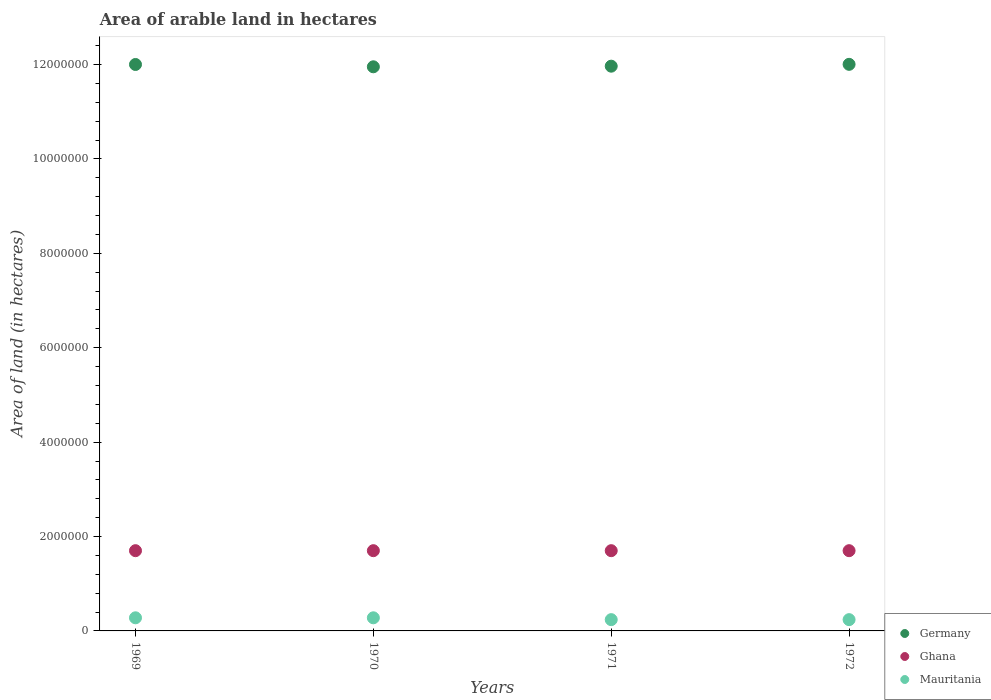What is the total arable land in Ghana in 1972?
Ensure brevity in your answer.  1.70e+06. Across all years, what is the maximum total arable land in Germany?
Your response must be concise. 1.20e+07. Across all years, what is the minimum total arable land in Ghana?
Offer a terse response. 1.70e+06. In which year was the total arable land in Mauritania maximum?
Your answer should be compact. 1969. What is the total total arable land in Germany in the graph?
Provide a succinct answer. 4.79e+07. What is the difference between the total arable land in Germany in 1969 and that in 1970?
Give a very brief answer. 4.90e+04. What is the difference between the total arable land in Germany in 1969 and the total arable land in Mauritania in 1970?
Ensure brevity in your answer.  1.17e+07. What is the average total arable land in Ghana per year?
Offer a very short reply. 1.70e+06. In the year 1972, what is the difference between the total arable land in Germany and total arable land in Ghana?
Your response must be concise. 1.03e+07. What is the ratio of the total arable land in Mauritania in 1969 to that in 1971?
Ensure brevity in your answer.  1.16. Is the total arable land in Germany in 1969 less than that in 1971?
Ensure brevity in your answer.  No. What is the difference between the highest and the second highest total arable land in Mauritania?
Offer a very short reply. 0. What is the difference between the highest and the lowest total arable land in Mauritania?
Keep it short and to the point. 3.90e+04. In how many years, is the total arable land in Mauritania greater than the average total arable land in Mauritania taken over all years?
Offer a very short reply. 2. How many legend labels are there?
Provide a succinct answer. 3. How are the legend labels stacked?
Ensure brevity in your answer.  Vertical. What is the title of the graph?
Offer a terse response. Area of arable land in hectares. Does "Sweden" appear as one of the legend labels in the graph?
Offer a very short reply. No. What is the label or title of the X-axis?
Offer a terse response. Years. What is the label or title of the Y-axis?
Your answer should be compact. Area of land (in hectares). What is the Area of land (in hectares) of Germany in 1969?
Provide a short and direct response. 1.20e+07. What is the Area of land (in hectares) of Ghana in 1969?
Ensure brevity in your answer.  1.70e+06. What is the Area of land (in hectares) of Mauritania in 1969?
Give a very brief answer. 2.78e+05. What is the Area of land (in hectares) of Germany in 1970?
Your answer should be compact. 1.20e+07. What is the Area of land (in hectares) in Ghana in 1970?
Provide a succinct answer. 1.70e+06. What is the Area of land (in hectares) in Mauritania in 1970?
Your answer should be very brief. 2.78e+05. What is the Area of land (in hectares) in Germany in 1971?
Give a very brief answer. 1.20e+07. What is the Area of land (in hectares) of Ghana in 1971?
Provide a succinct answer. 1.70e+06. What is the Area of land (in hectares) in Mauritania in 1971?
Give a very brief answer. 2.39e+05. What is the Area of land (in hectares) in Germany in 1972?
Offer a very short reply. 1.20e+07. What is the Area of land (in hectares) of Ghana in 1972?
Your answer should be compact. 1.70e+06. What is the Area of land (in hectares) of Mauritania in 1972?
Ensure brevity in your answer.  2.39e+05. Across all years, what is the maximum Area of land (in hectares) of Germany?
Provide a short and direct response. 1.20e+07. Across all years, what is the maximum Area of land (in hectares) of Ghana?
Offer a terse response. 1.70e+06. Across all years, what is the maximum Area of land (in hectares) of Mauritania?
Offer a very short reply. 2.78e+05. Across all years, what is the minimum Area of land (in hectares) in Germany?
Offer a very short reply. 1.20e+07. Across all years, what is the minimum Area of land (in hectares) in Ghana?
Offer a very short reply. 1.70e+06. Across all years, what is the minimum Area of land (in hectares) of Mauritania?
Keep it short and to the point. 2.39e+05. What is the total Area of land (in hectares) in Germany in the graph?
Make the answer very short. 4.79e+07. What is the total Area of land (in hectares) of Ghana in the graph?
Your answer should be compact. 6.80e+06. What is the total Area of land (in hectares) of Mauritania in the graph?
Make the answer very short. 1.03e+06. What is the difference between the Area of land (in hectares) of Germany in 1969 and that in 1970?
Keep it short and to the point. 4.90e+04. What is the difference between the Area of land (in hectares) in Ghana in 1969 and that in 1970?
Your response must be concise. 0. What is the difference between the Area of land (in hectares) in Germany in 1969 and that in 1971?
Offer a terse response. 3.60e+04. What is the difference between the Area of land (in hectares) of Mauritania in 1969 and that in 1971?
Your answer should be very brief. 3.90e+04. What is the difference between the Area of land (in hectares) in Germany in 1969 and that in 1972?
Your response must be concise. -3000. What is the difference between the Area of land (in hectares) of Mauritania in 1969 and that in 1972?
Keep it short and to the point. 3.90e+04. What is the difference between the Area of land (in hectares) in Germany in 1970 and that in 1971?
Give a very brief answer. -1.30e+04. What is the difference between the Area of land (in hectares) in Mauritania in 1970 and that in 1971?
Ensure brevity in your answer.  3.90e+04. What is the difference between the Area of land (in hectares) in Germany in 1970 and that in 1972?
Provide a short and direct response. -5.20e+04. What is the difference between the Area of land (in hectares) of Mauritania in 1970 and that in 1972?
Provide a succinct answer. 3.90e+04. What is the difference between the Area of land (in hectares) of Germany in 1971 and that in 1972?
Offer a terse response. -3.90e+04. What is the difference between the Area of land (in hectares) of Mauritania in 1971 and that in 1972?
Your answer should be compact. 0. What is the difference between the Area of land (in hectares) of Germany in 1969 and the Area of land (in hectares) of Ghana in 1970?
Keep it short and to the point. 1.03e+07. What is the difference between the Area of land (in hectares) in Germany in 1969 and the Area of land (in hectares) in Mauritania in 1970?
Make the answer very short. 1.17e+07. What is the difference between the Area of land (in hectares) of Ghana in 1969 and the Area of land (in hectares) of Mauritania in 1970?
Give a very brief answer. 1.42e+06. What is the difference between the Area of land (in hectares) in Germany in 1969 and the Area of land (in hectares) in Ghana in 1971?
Your answer should be very brief. 1.03e+07. What is the difference between the Area of land (in hectares) in Germany in 1969 and the Area of land (in hectares) in Mauritania in 1971?
Provide a short and direct response. 1.18e+07. What is the difference between the Area of land (in hectares) in Ghana in 1969 and the Area of land (in hectares) in Mauritania in 1971?
Make the answer very short. 1.46e+06. What is the difference between the Area of land (in hectares) of Germany in 1969 and the Area of land (in hectares) of Ghana in 1972?
Offer a very short reply. 1.03e+07. What is the difference between the Area of land (in hectares) of Germany in 1969 and the Area of land (in hectares) of Mauritania in 1972?
Give a very brief answer. 1.18e+07. What is the difference between the Area of land (in hectares) in Ghana in 1969 and the Area of land (in hectares) in Mauritania in 1972?
Provide a succinct answer. 1.46e+06. What is the difference between the Area of land (in hectares) in Germany in 1970 and the Area of land (in hectares) in Ghana in 1971?
Provide a succinct answer. 1.03e+07. What is the difference between the Area of land (in hectares) in Germany in 1970 and the Area of land (in hectares) in Mauritania in 1971?
Your response must be concise. 1.17e+07. What is the difference between the Area of land (in hectares) of Ghana in 1970 and the Area of land (in hectares) of Mauritania in 1971?
Offer a very short reply. 1.46e+06. What is the difference between the Area of land (in hectares) of Germany in 1970 and the Area of land (in hectares) of Ghana in 1972?
Your answer should be compact. 1.03e+07. What is the difference between the Area of land (in hectares) in Germany in 1970 and the Area of land (in hectares) in Mauritania in 1972?
Your answer should be very brief. 1.17e+07. What is the difference between the Area of land (in hectares) of Ghana in 1970 and the Area of land (in hectares) of Mauritania in 1972?
Provide a succinct answer. 1.46e+06. What is the difference between the Area of land (in hectares) of Germany in 1971 and the Area of land (in hectares) of Ghana in 1972?
Provide a short and direct response. 1.03e+07. What is the difference between the Area of land (in hectares) of Germany in 1971 and the Area of land (in hectares) of Mauritania in 1972?
Provide a short and direct response. 1.17e+07. What is the difference between the Area of land (in hectares) in Ghana in 1971 and the Area of land (in hectares) in Mauritania in 1972?
Your answer should be very brief. 1.46e+06. What is the average Area of land (in hectares) of Germany per year?
Offer a terse response. 1.20e+07. What is the average Area of land (in hectares) in Ghana per year?
Provide a short and direct response. 1.70e+06. What is the average Area of land (in hectares) in Mauritania per year?
Offer a very short reply. 2.58e+05. In the year 1969, what is the difference between the Area of land (in hectares) of Germany and Area of land (in hectares) of Ghana?
Your answer should be very brief. 1.03e+07. In the year 1969, what is the difference between the Area of land (in hectares) in Germany and Area of land (in hectares) in Mauritania?
Your response must be concise. 1.17e+07. In the year 1969, what is the difference between the Area of land (in hectares) in Ghana and Area of land (in hectares) in Mauritania?
Provide a succinct answer. 1.42e+06. In the year 1970, what is the difference between the Area of land (in hectares) of Germany and Area of land (in hectares) of Ghana?
Your answer should be compact. 1.03e+07. In the year 1970, what is the difference between the Area of land (in hectares) in Germany and Area of land (in hectares) in Mauritania?
Your answer should be very brief. 1.17e+07. In the year 1970, what is the difference between the Area of land (in hectares) of Ghana and Area of land (in hectares) of Mauritania?
Offer a terse response. 1.42e+06. In the year 1971, what is the difference between the Area of land (in hectares) of Germany and Area of land (in hectares) of Ghana?
Your answer should be compact. 1.03e+07. In the year 1971, what is the difference between the Area of land (in hectares) of Germany and Area of land (in hectares) of Mauritania?
Provide a succinct answer. 1.17e+07. In the year 1971, what is the difference between the Area of land (in hectares) in Ghana and Area of land (in hectares) in Mauritania?
Your answer should be very brief. 1.46e+06. In the year 1972, what is the difference between the Area of land (in hectares) in Germany and Area of land (in hectares) in Ghana?
Make the answer very short. 1.03e+07. In the year 1972, what is the difference between the Area of land (in hectares) in Germany and Area of land (in hectares) in Mauritania?
Offer a very short reply. 1.18e+07. In the year 1972, what is the difference between the Area of land (in hectares) in Ghana and Area of land (in hectares) in Mauritania?
Your answer should be compact. 1.46e+06. What is the ratio of the Area of land (in hectares) of Germany in 1969 to that in 1970?
Give a very brief answer. 1. What is the ratio of the Area of land (in hectares) of Ghana in 1969 to that in 1970?
Keep it short and to the point. 1. What is the ratio of the Area of land (in hectares) of Germany in 1969 to that in 1971?
Make the answer very short. 1. What is the ratio of the Area of land (in hectares) of Ghana in 1969 to that in 1971?
Keep it short and to the point. 1. What is the ratio of the Area of land (in hectares) in Mauritania in 1969 to that in 1971?
Offer a terse response. 1.16. What is the ratio of the Area of land (in hectares) in Ghana in 1969 to that in 1972?
Ensure brevity in your answer.  1. What is the ratio of the Area of land (in hectares) in Mauritania in 1969 to that in 1972?
Make the answer very short. 1.16. What is the ratio of the Area of land (in hectares) of Germany in 1970 to that in 1971?
Make the answer very short. 1. What is the ratio of the Area of land (in hectares) in Mauritania in 1970 to that in 1971?
Make the answer very short. 1.16. What is the ratio of the Area of land (in hectares) of Germany in 1970 to that in 1972?
Offer a very short reply. 1. What is the ratio of the Area of land (in hectares) of Mauritania in 1970 to that in 1972?
Your answer should be very brief. 1.16. What is the ratio of the Area of land (in hectares) of Germany in 1971 to that in 1972?
Ensure brevity in your answer.  1. What is the ratio of the Area of land (in hectares) in Ghana in 1971 to that in 1972?
Your response must be concise. 1. What is the ratio of the Area of land (in hectares) of Mauritania in 1971 to that in 1972?
Give a very brief answer. 1. What is the difference between the highest and the second highest Area of land (in hectares) in Germany?
Make the answer very short. 3000. What is the difference between the highest and the second highest Area of land (in hectares) in Mauritania?
Keep it short and to the point. 0. What is the difference between the highest and the lowest Area of land (in hectares) of Germany?
Your answer should be very brief. 5.20e+04. What is the difference between the highest and the lowest Area of land (in hectares) of Ghana?
Offer a very short reply. 0. What is the difference between the highest and the lowest Area of land (in hectares) of Mauritania?
Ensure brevity in your answer.  3.90e+04. 